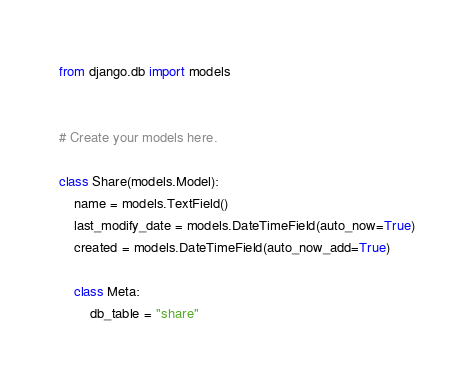Convert code to text. <code><loc_0><loc_0><loc_500><loc_500><_Python_>from django.db import models


# Create your models here.

class Share(models.Model):
    name = models.TextField()
    last_modify_date = models.DateTimeField(auto_now=True)
    created = models.DateTimeField(auto_now_add=True)

    class Meta:
        db_table = "share"
</code> 